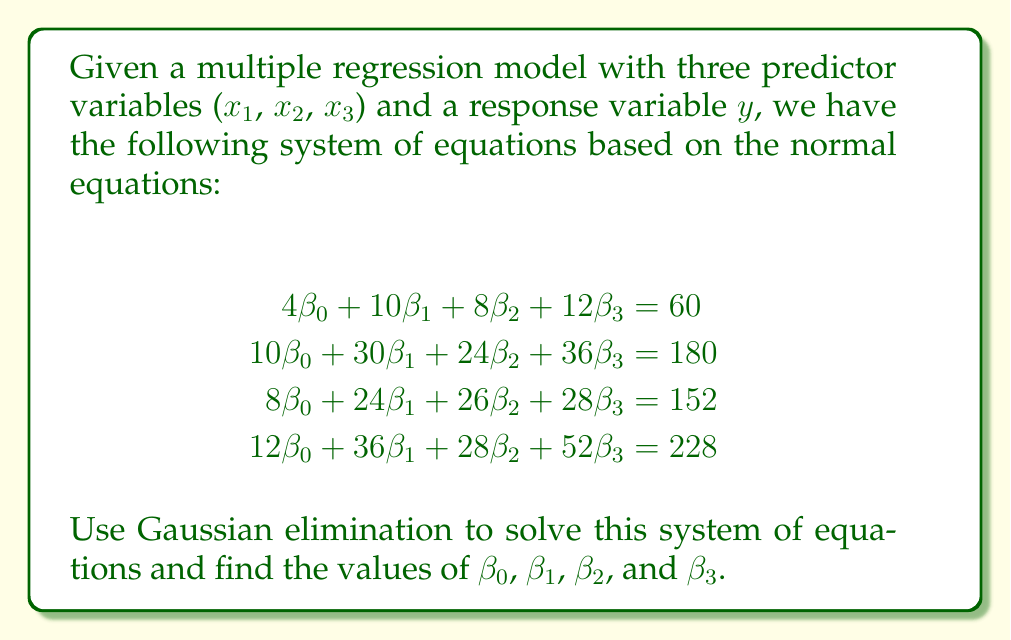What is the answer to this math problem? To solve this system using Gaussian elimination, we'll follow these steps:

1) First, write the augmented matrix:

$$
\begin{bmatrix}
4 & 10 & 8 & 12 & | & 60 \\
10 & 30 & 24 & 36 & | & 180 \\
8 & 24 & 26 & 28 & | & 152 \\
12 & 36 & 28 & 52 & | & 228
\end{bmatrix}
$$

2) Multiply the first row by -2.5 and add to the second row:

$$
\begin{bmatrix}
4 & 10 & 8 & 12 & | & 60 \\
0 & 5 & 4 & 6 & | & 30 \\
8 & 24 & 26 & 28 & | & 152 \\
12 & 36 & 28 & 52 & | & 228
\end{bmatrix}
$$

3) Multiply the first row by -2 and add to the third row:

$$
\begin{bmatrix}
4 & 10 & 8 & 12 & | & 60 \\
0 & 5 & 4 & 6 & | & 30 \\
0 & 4 & 10 & 4 & | & 32 \\
12 & 36 & 28 & 52 & | & 228
\end{bmatrix}
$$

4) Multiply the first row by -3 and add to the fourth row:

$$
\begin{bmatrix}
4 & 10 & 8 & 12 & | & 60 \\
0 & 5 & 4 & 6 & | & 30 \\
0 & 4 & 10 & 4 & | & 32 \\
0 & 6 & 4 & 16 & | & 48
\end{bmatrix}
$$

5) Multiply the second row by -0.8 and add to the third row:

$$
\begin{bmatrix}
4 & 10 & 8 & 12 & | & 60 \\
0 & 5 & 4 & 6 & | & 30 \\
0 & 0 & 6.8 & -0.8 & | & 8 \\
0 & 6 & 4 & 16 & | & 48
\end{bmatrix}
$$

6) Multiply the second row by -1.2 and add to the fourth row:

$$
\begin{bmatrix}
4 & 10 & 8 & 12 & | & 60 \\
0 & 5 & 4 & 6 & | & 30 \\
0 & 0 & 6.8 & -0.8 & | & 8 \\
0 & 0 & -0.8 & 8.8 & | & 12
\end{bmatrix}
$$

7) Multiply the third row by 0.1176 and add to the fourth row:

$$
\begin{bmatrix}
4 & 10 & 8 & 12 & | & 60 \\
0 & 5 & 4 & 6 & | & 30 \\
0 & 0 & 6.8 & -0.8 & | & 8 \\
0 & 0 & 0 & 8.7059 & | & 12.9412
\end{bmatrix}
$$

8) Now we have an upper triangular matrix. We can solve for $\beta_3$:

$\beta_3 = 12.9412 / 8.7059 = 1.4865$

9) Substitute this value back into the third equation to solve for $\beta_2$:

$6.8\beta_2 - 0.8(1.4865) = 8$
$6.8\beta_2 = 9.1892$
$\beta_2 = 1.3514$

10) Substitute these values into the second equation to solve for $\beta_1$:

$5\beta_1 + 4(1.3514) + 6(1.4865) = 30$
$5\beta_1 = 30 - 5.4056 - 8.919 = 15.6754$
$\beta_1 = 3.1351$

11) Finally, substitute all values into the first equation to solve for $\beta_0$:

$4\beta_0 + 10(3.1351) + 8(1.3514) + 12(1.4865) = 60$
$4\beta_0 = 60 - 31.351 - 10.8112 - 17.838 = 0$
$\beta_0 = 0$

Therefore, the solution is $\beta_0 = 0$, $\beta_1 = 3.1351$, $\beta_2 = 1.3514$, and $\beta_3 = 1.4865$.
Answer: $\beta_0 = 0$, $\beta_1 = 3.1351$, $\beta_2 = 1.3514$, $\beta_3 = 1.4865$ 